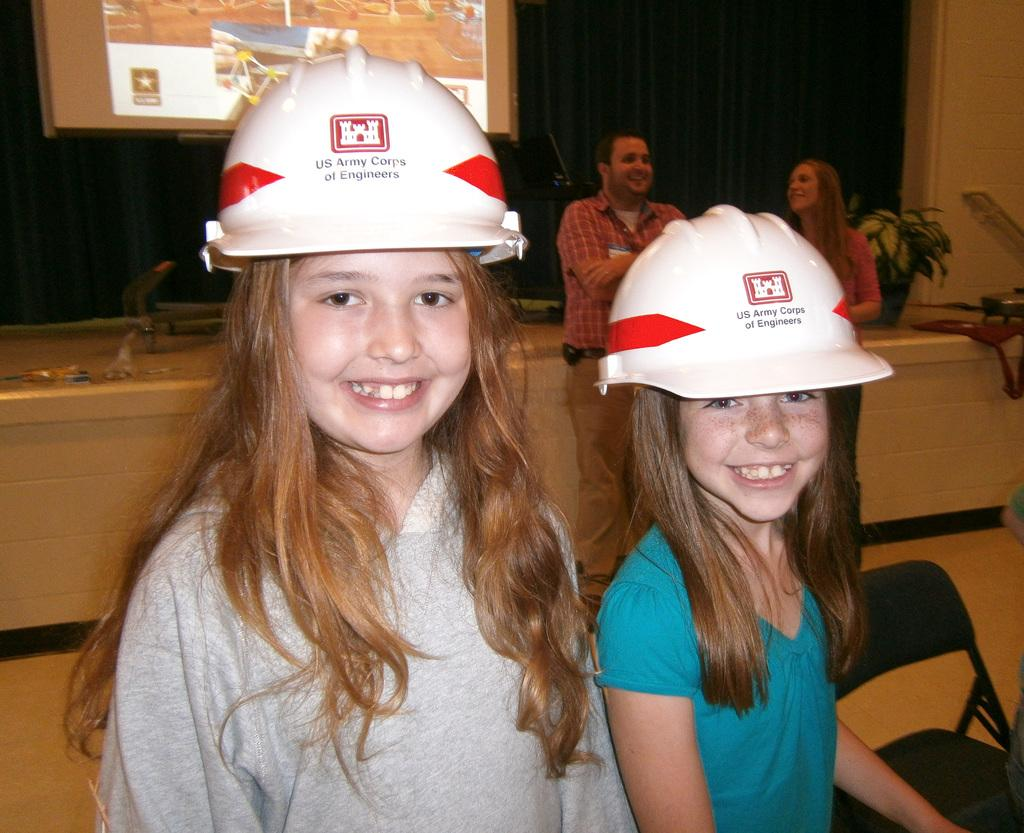How many people are in the image? There are people in the image, but the exact number is not specified. What are two people wearing in the image? Two people are wearing helmets in the image. What can be seen in the image besides people and helmets? There is a flowerpot, a projection screen, and chairs in the image. What other objects are present in the image? There are other objects present in the image, but their specific nature is not mentioned. What type of cracker is being served on the secretary's desk in the image? There is no mention of a secretary or a cracker in the image, so this question cannot be answered. 